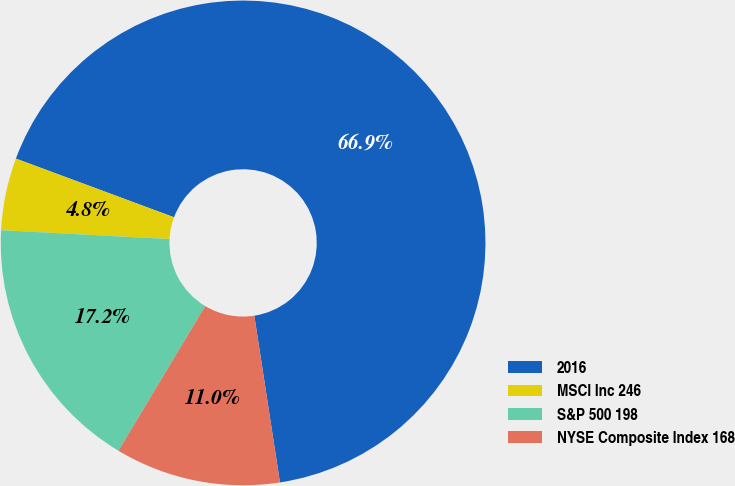<chart> <loc_0><loc_0><loc_500><loc_500><pie_chart><fcel>2016<fcel>MSCI Inc 246<fcel>S&P 500 198<fcel>NYSE Composite Index 168<nl><fcel>66.92%<fcel>4.82%<fcel>17.24%<fcel>11.03%<nl></chart> 